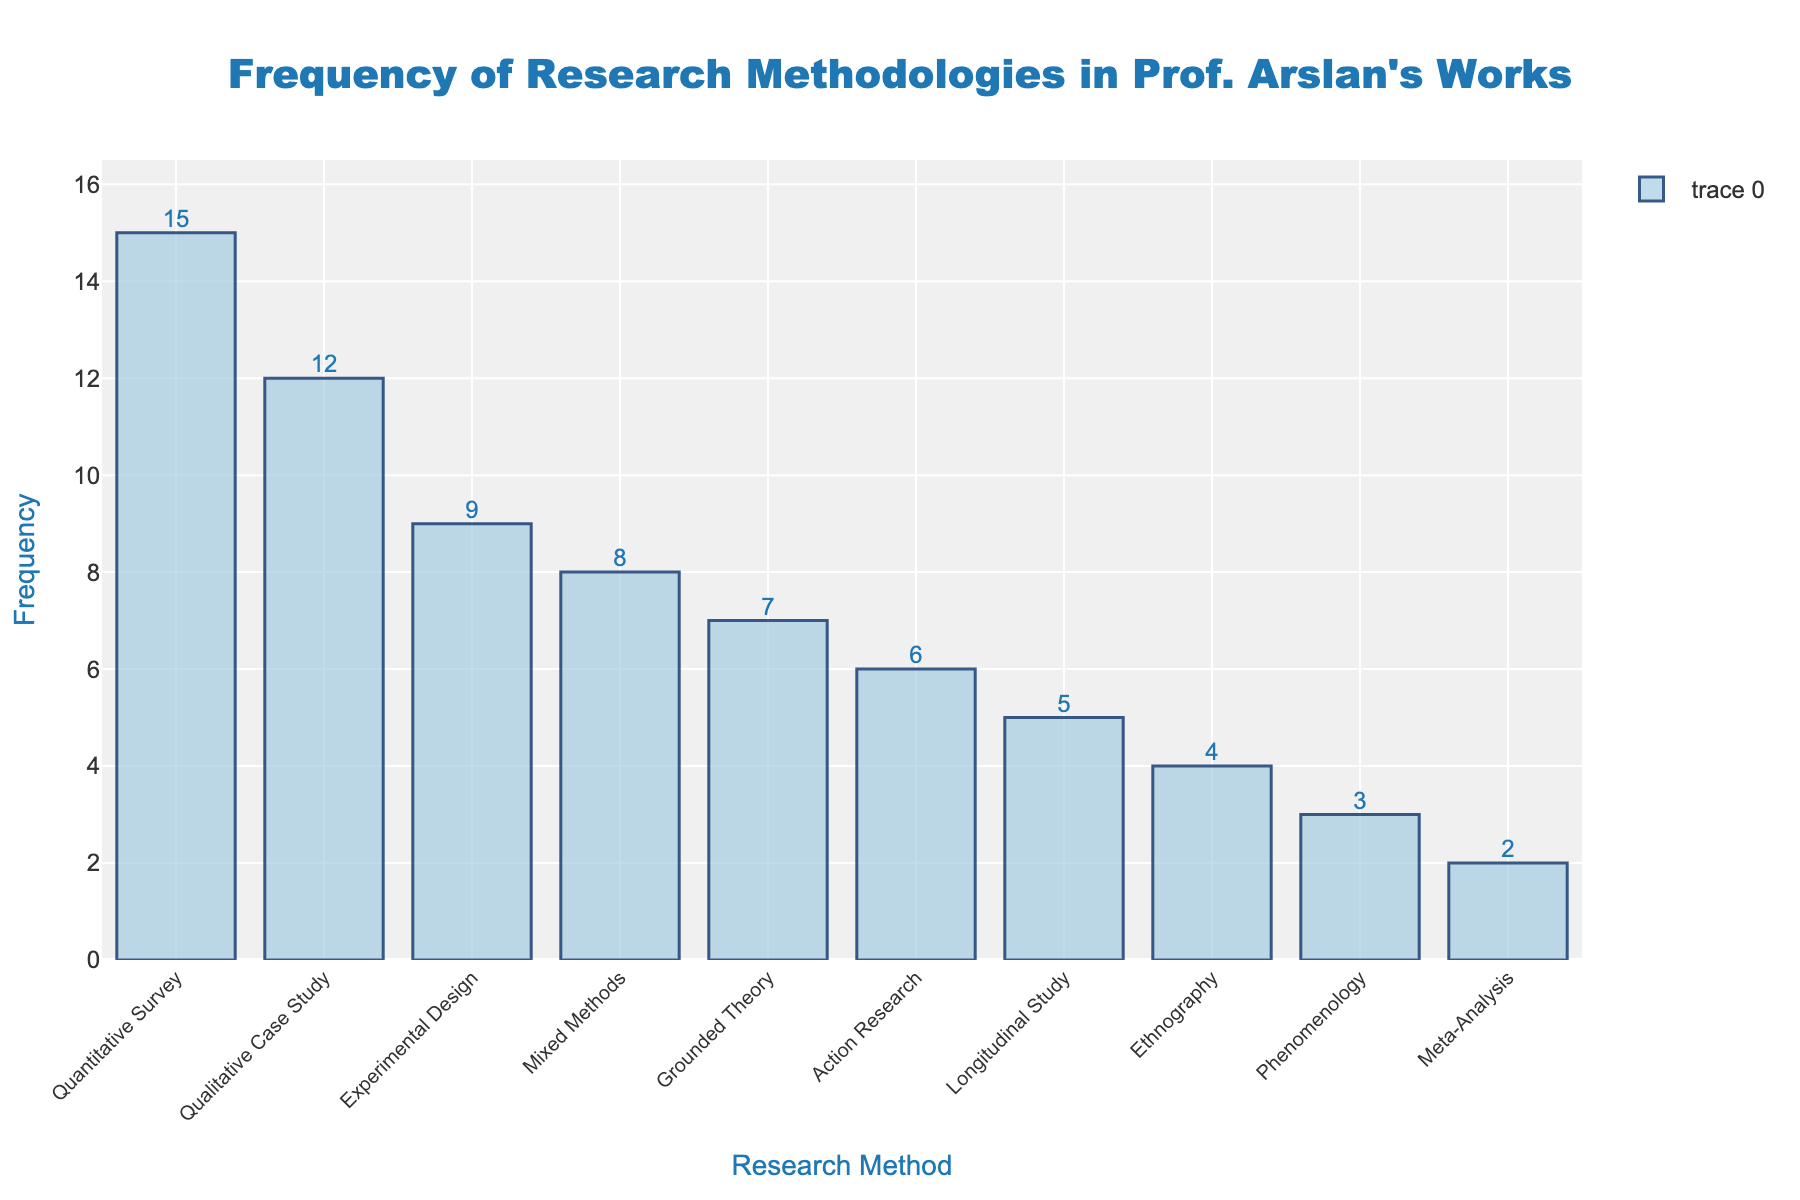Which research method is used most frequently in Prof. Arslan's works? By inspecting the chart, the highest bar represents the "Quantitative Survey" method.
Answer: Quantitative Survey Which research method has the lowest frequency in Prof. Arslan's works? The shortest bar corresponds to "Meta-Analysis".
Answer: Meta-Analysis How many research methods in the chart have a frequency greater than or equal to 10? By counting the bars that reach or exceed a height of 10, it includes "Quantitative Survey" and "Qualitative Case Study".
Answer: 2 What's the combined frequency of "Qualitative Case Study" and "Mixed Methods"? Adding the frequencies from the bars labeled "Qualitative Case Study" (12) and "Mixed Methods" (8) yields 12 + 8 = 20.
Answer: 20 Which research methods have higher frequencies than "Experimental Design"? By comparing bars, "Quantitative Survey" (15) and "Qualitative Case Study" (12) are both higher than "Experimental Design" (9).
Answer: Quantitative Survey, Qualitative Case Study What is the difference in frequency between "Grounded Theory" and "Action Research"? Subtracting the frequency of "Action Research" (6) from "Grounded Theory" (7) yields 7 - 6 = 1.
Answer: 1 Which research methods have lower frequencies than "Longitudinal Study"? Comparing bars to "Longitudinal Study" (5), "Ethnography" (4), "Phenomenology" (3), and "Meta-Analysis" (2) are all lower.
Answer: Ethnography, Phenomenology, Meta-Analysis What's the average frequency of the top three most frequently used research methods? First, identify the frequencies of the top three methods: "Quantitative Survey" (15), "Qualitative Case Study" (12), and "Experimental Design" (9). Then, calculate the average: (15 + 12 + 9) / 3 = 12.
Answer: 12 What's the total frequency of all the research methodologies combined? Sum all the frequencies: 12 + 8 + 15 + 6 + 4 + 7 + 3 + 9 + 5 + 2 = 71.
Answer: 71 How many research methods have a frequency within the range of 2 to 6 inclusive? Counting the bars falling between 2 and 6 includes "Meta-Analysis" (2), "Longitudinal Study" (5), "Action Research" (6), and "Ethnography" (4).
Answer: 4 